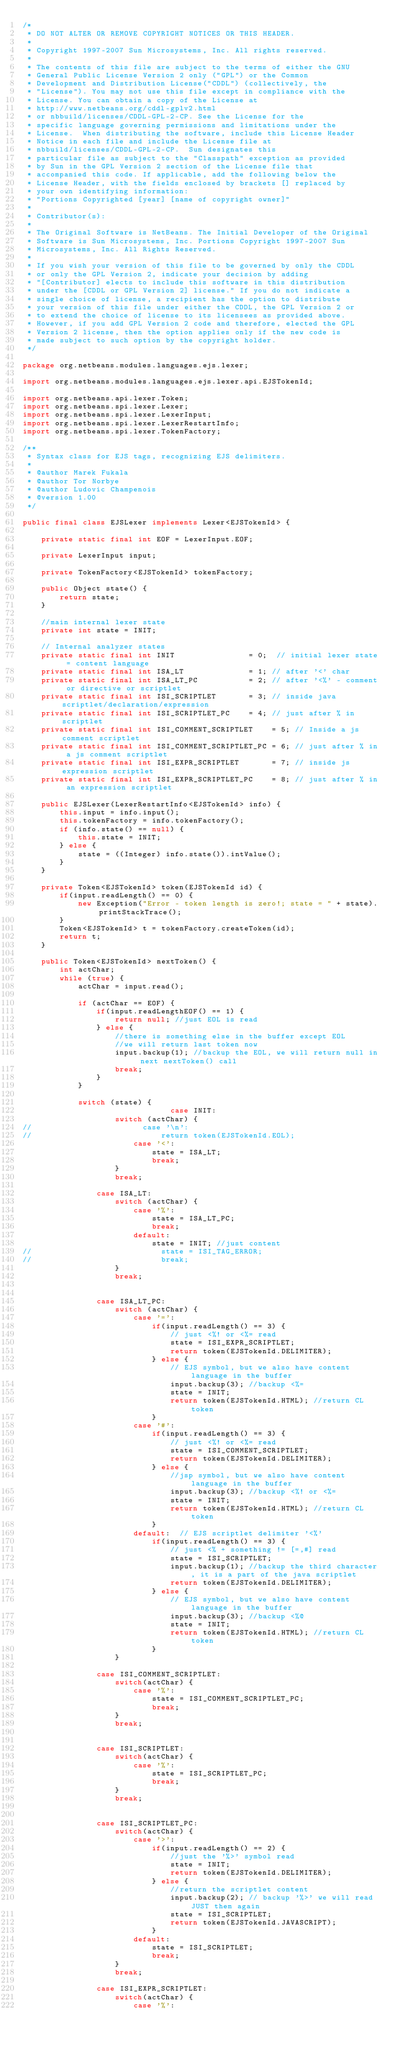<code> <loc_0><loc_0><loc_500><loc_500><_Java_>/*
 * DO NOT ALTER OR REMOVE COPYRIGHT NOTICES OR THIS HEADER.
 *
 * Copyright 1997-2007 Sun Microsystems, Inc. All rights reserved.
 *
 * The contents of this file are subject to the terms of either the GNU
 * General Public License Version 2 only ("GPL") or the Common
 * Development and Distribution License("CDDL") (collectively, the
 * "License"). You may not use this file except in compliance with the
 * License. You can obtain a copy of the License at
 * http://www.netbeans.org/cddl-gplv2.html
 * or nbbuild/licenses/CDDL-GPL-2-CP. See the License for the
 * specific language governing permissions and limitations under the
 * License.  When distributing the software, include this License Header
 * Notice in each file and include the License file at
 * nbbuild/licenses/CDDL-GPL-2-CP.  Sun designates this
 * particular file as subject to the "Classpath" exception as provided
 * by Sun in the GPL Version 2 section of the License file that
 * accompanied this code. If applicable, add the following below the
 * License Header, with the fields enclosed by brackets [] replaced by
 * your own identifying information:
 * "Portions Copyrighted [year] [name of copyright owner]"
 *
 * Contributor(s):
 *
 * The Original Software is NetBeans. The Initial Developer of the Original
 * Software is Sun Microsystems, Inc. Portions Copyright 1997-2007 Sun
 * Microsystems, Inc. All Rights Reserved.
 *
 * If you wish your version of this file to be governed by only the CDDL
 * or only the GPL Version 2, indicate your decision by adding
 * "[Contributor] elects to include this software in this distribution
 * under the [CDDL or GPL Version 2] license." If you do not indicate a
 * single choice of license, a recipient has the option to distribute
 * your version of this file under either the CDDL, the GPL Version 2 or
 * to extend the choice of license to its licensees as provided above.
 * However, if you add GPL Version 2 code and therefore, elected the GPL
 * Version 2 license, then the option applies only if the new code is
 * made subject to such option by the copyright holder.
 */

package org.netbeans.modules.languages.ejs.lexer;

import org.netbeans.modules.languages.ejs.lexer.api.EJSTokenId;

import org.netbeans.api.lexer.Token;
import org.netbeans.spi.lexer.Lexer;
import org.netbeans.spi.lexer.LexerInput;
import org.netbeans.spi.lexer.LexerRestartInfo;
import org.netbeans.spi.lexer.TokenFactory;

/**
 * Syntax class for EJS tags, recognizing EJS delimiters.
 *
 * @author Marek Fukala
 * @author Tor Norbye
 * @author Ludovic Champenois
 * @version 1.00
 */

public final class EJSLexer implements Lexer<EJSTokenId> {
    
    private static final int EOF = LexerInput.EOF;
    
    private LexerInput input;
    
    private TokenFactory<EJSTokenId> tokenFactory;
    
    public Object state() {
        return state;
    }
    
    //main internal lexer state
    private int state = INIT;
    
    // Internal analyzer states
    private static final int INIT                = 0;  // initial lexer state = content language
    private static final int ISA_LT              = 1; // after '<' char
    private static final int ISA_LT_PC           = 2; // after '<%' - comment or directive or scriptlet
    private static final int ISI_SCRIPTLET       = 3; // inside java scriptlet/declaration/expression
    private static final int ISI_SCRIPTLET_PC    = 4; // just after % in scriptlet
    private static final int ISI_COMMENT_SCRIPTLET    = 5; // Inside a js comment scriptlet
    private static final int ISI_COMMENT_SCRIPTLET_PC = 6; // just after % in a js comment scriptlet
    private static final int ISI_EXPR_SCRIPTLET       = 7; // inside js expression scriptlet
    private static final int ISI_EXPR_SCRIPTLET_PC    = 8; // just after % in an expression scriptlet
    
    public EJSLexer(LexerRestartInfo<EJSTokenId> info) {
        this.input = info.input();
        this.tokenFactory = info.tokenFactory();
        if (info.state() == null) {
            this.state = INIT;
        } else {
            state = ((Integer) info.state()).intValue();
        }
    }
    
    private Token<EJSTokenId> token(EJSTokenId id) {
        if(input.readLength() == 0) {
            new Exception("Error - token length is zero!; state = " + state).printStackTrace();
        }
        Token<EJSTokenId> t = tokenFactory.createToken(id);
        return t;
    }
    
    public Token<EJSTokenId> nextToken() {
        int actChar;
        while (true) {
            actChar = input.read();
            
            if (actChar == EOF) {
                if(input.readLengthEOF() == 1) {
                    return null; //just EOL is read
                } else {
                    //there is something else in the buffer except EOL
                    //we will return last token now
                    input.backup(1); //backup the EOL, we will return null in next nextToken() call
                    break;
                }
            }
            
            switch (state) {
                                case INIT:
                    switch (actChar) {
//                        case '\n':
//                            return token(EJSTokenId.EOL);
                        case '<':
                            state = ISA_LT;
                            break;
                    }
                    break;
                    
                case ISA_LT:
                    switch (actChar) {
                        case '%':
                            state = ISA_LT_PC;
                            break;
                        default:
                            state = INIT; //just content
//                            state = ISI_TAG_ERROR;
//                            break;
                    }
                    break;

                                        
                case ISA_LT_PC:
                    switch (actChar) {
                        case '=': 
                            if(input.readLength() == 3) {
                                // just <%! or <%= read
                                state = ISI_EXPR_SCRIPTLET;
                                return token(EJSTokenId.DELIMITER);
                            } else {
                                // EJS symbol, but we also have content language in the buffer
                                input.backup(3); //backup <%=
                                state = INIT;
                                return token(EJSTokenId.HTML); //return CL token
                            }
                        case '#':
                            if(input.readLength() == 3) {
                                // just <%! or <%= read
                                state = ISI_COMMENT_SCRIPTLET;
                                return token(EJSTokenId.DELIMITER);
                            } else {
                                //jsp symbol, but we also have content language in the buffer
                                input.backup(3); //backup <%! or <%=
                                state = INIT;
                                return token(EJSTokenId.HTML); //return CL token
                            }
                        default:  // EJS scriptlet delimiter '<%'
                            if(input.readLength() == 3) {
                                // just <% + something != [=,#] read
                                state = ISI_SCRIPTLET;
                                input.backup(1); //backup the third character, it is a part of the java scriptlet
                                return token(EJSTokenId.DELIMITER);
                            } else {
                                // EJS symbol, but we also have content language in the buffer
                                input.backup(3); //backup <%@
                                state = INIT;
                                return token(EJSTokenId.HTML); //return CL token
                            }
                    }
                    
                case ISI_COMMENT_SCRIPTLET:
                    switch(actChar) {
                        case '%':
                            state = ISI_COMMENT_SCRIPTLET_PC;
                            break;
                    }
                    break;
                    
                    
                case ISI_SCRIPTLET:
                    switch(actChar) {
                        case '%':
                            state = ISI_SCRIPTLET_PC;
                            break;
                    }
                    break;
                    

                case ISI_SCRIPTLET_PC:
                    switch(actChar) {
                        case '>':
                            if(input.readLength() == 2) {
                                //just the '%>' symbol read
                                state = INIT;
                                return token(EJSTokenId.DELIMITER);
                            } else {
                                //return the scriptlet content
                                input.backup(2); // backup '%>' we will read JUST them again
                                state = ISI_SCRIPTLET;
                                return token(EJSTokenId.JAVASCRIPT);
                            }
                        default:
                            state = ISI_SCRIPTLET;
                            break;
                    }
                    break;

                case ISI_EXPR_SCRIPTLET:
                    switch(actChar) {
                        case '%':</code> 